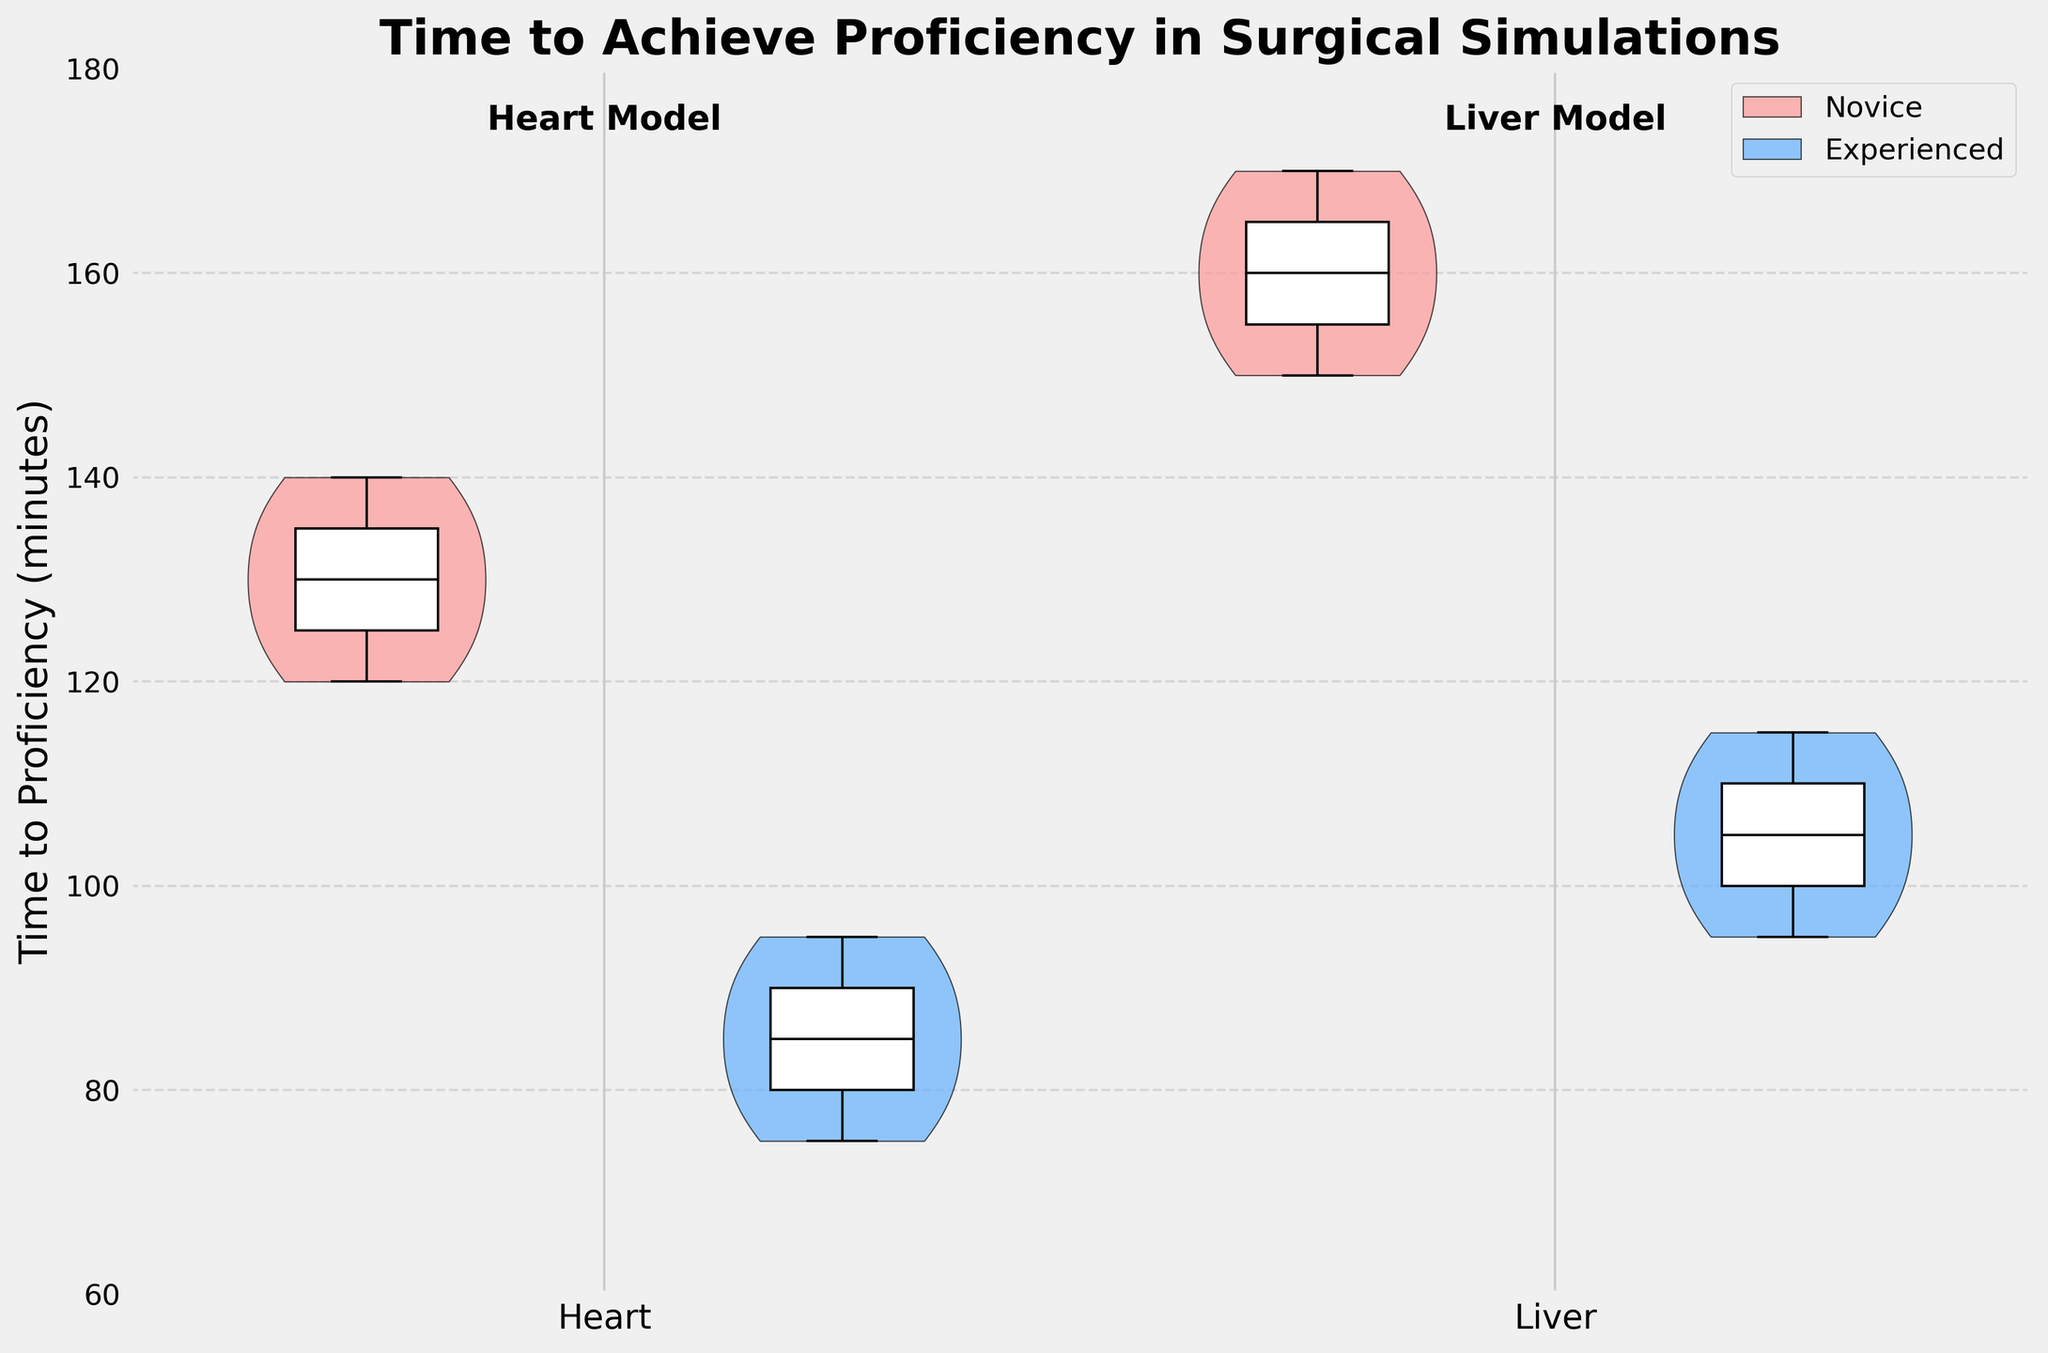What is the title of the plot? The title of the plot is written at the top and aims to describe the data shown in the visualization. In this case, the title reads "Time to Achieve Proficiency in Surgical Simulations".
Answer: Time to Achieve Proficiency in Surgical Simulations What is the y-axis label of the plot? The y-axis label describes the metric measured vertically in the plot. Here, it reads "Time to Proficiency (minutes)".
Answer: Time to Proficiency (minutes) Which organ model, Heart or Liver, generally takes more time for novices to achieve proficiency? By comparing the spread of the violins and the boxplots within them, it is evident that the Liver model takes more time for novices, as the distribution is centered at a higher value range compared to the Heart model.
Answer: Liver Do experienced surgeons achieve proficiency faster than novice surgeons on the Heart model? We observe that the distribution for experienced surgeons is centered at lower values compared to novices for the Heart model. Hence, experienced surgeons achieve proficiency faster.
Answer: Yes What is the range of proficiency times for novice surgeons using the Liver model? The range can be observed by looking at the extremes of the boxplot within the violin plot. It ranges from 150 to 170 minutes.
Answer: 150 to 170 minutes What is the median time taken by experienced surgeons to achieve proficiency using the Heart model? The median time can be identified from the boxplot within the violin plot for experienced surgeons using the Heart model, which is the line inside the box. The median lies around 85 minutes.
Answer: 85 minutes Which group - novice or experienced - shows greater variation in proficiency times with the Liver model? Greater variation is indicated by a wider spread in the violin plot. The novice group shows a wider spread compared to the experienced group, indicating greater variation.
Answer: Novice Compare the median proficiency times for novices on the Heart model and experienced surgeons on the Liver model. The comparison involves identifying the median lines in the respective boxplots. The median for novices on the Heart model is approximately 130 minutes, while for experienced surgeons on the Liver model, it is around 105 minutes. Therefore, novices on the Heart model take longer.
Answer: Novices on the Heart model take longer Is there any overlap in proficiency times for novices and experienced surgeons on the Liver model? Overlap in proficiency times is indicated by overlapping sections of the violin plots. Here, there is some overlap between the lower range of novice times and the upper range of experienced times on the Liver model.
Answer: Yes Which group, novice or experienced surgeons, demonstrates a lower minimum proficiency time across both organ models? We check the lowest points of the violin plots for both groups across both organ models. The experienced surgeons have the lower minimum proficiency times compared to novice surgeons.
Answer: Experienced surgeons 